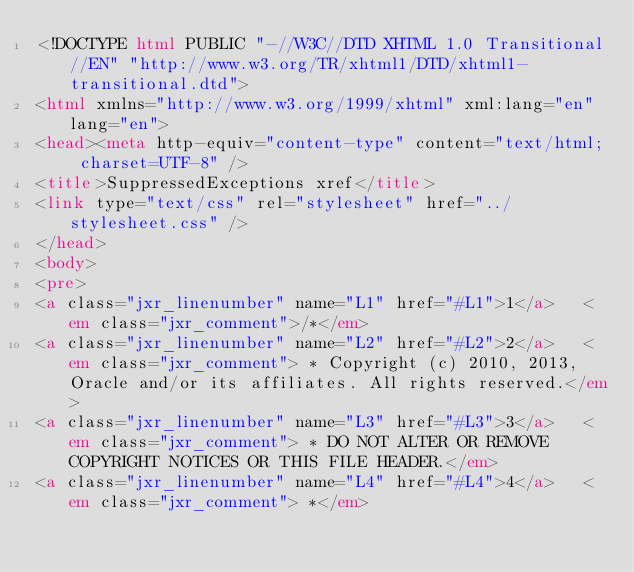Convert code to text. <code><loc_0><loc_0><loc_500><loc_500><_HTML_><!DOCTYPE html PUBLIC "-//W3C//DTD XHTML 1.0 Transitional//EN" "http://www.w3.org/TR/xhtml1/DTD/xhtml1-transitional.dtd">
<html xmlns="http://www.w3.org/1999/xhtml" xml:lang="en" lang="en">
<head><meta http-equiv="content-type" content="text/html; charset=UTF-8" />
<title>SuppressedExceptions xref</title>
<link type="text/css" rel="stylesheet" href="../stylesheet.css" />
</head>
<body>
<pre>
<a class="jxr_linenumber" name="L1" href="#L1">1</a>   <em class="jxr_comment">/*</em>
<a class="jxr_linenumber" name="L2" href="#L2">2</a>   <em class="jxr_comment"> * Copyright (c) 2010, 2013, Oracle and/or its affiliates. All rights reserved.</em>
<a class="jxr_linenumber" name="L3" href="#L3">3</a>   <em class="jxr_comment"> * DO NOT ALTER OR REMOVE COPYRIGHT NOTICES OR THIS FILE HEADER.</em>
<a class="jxr_linenumber" name="L4" href="#L4">4</a>   <em class="jxr_comment"> *</em></code> 